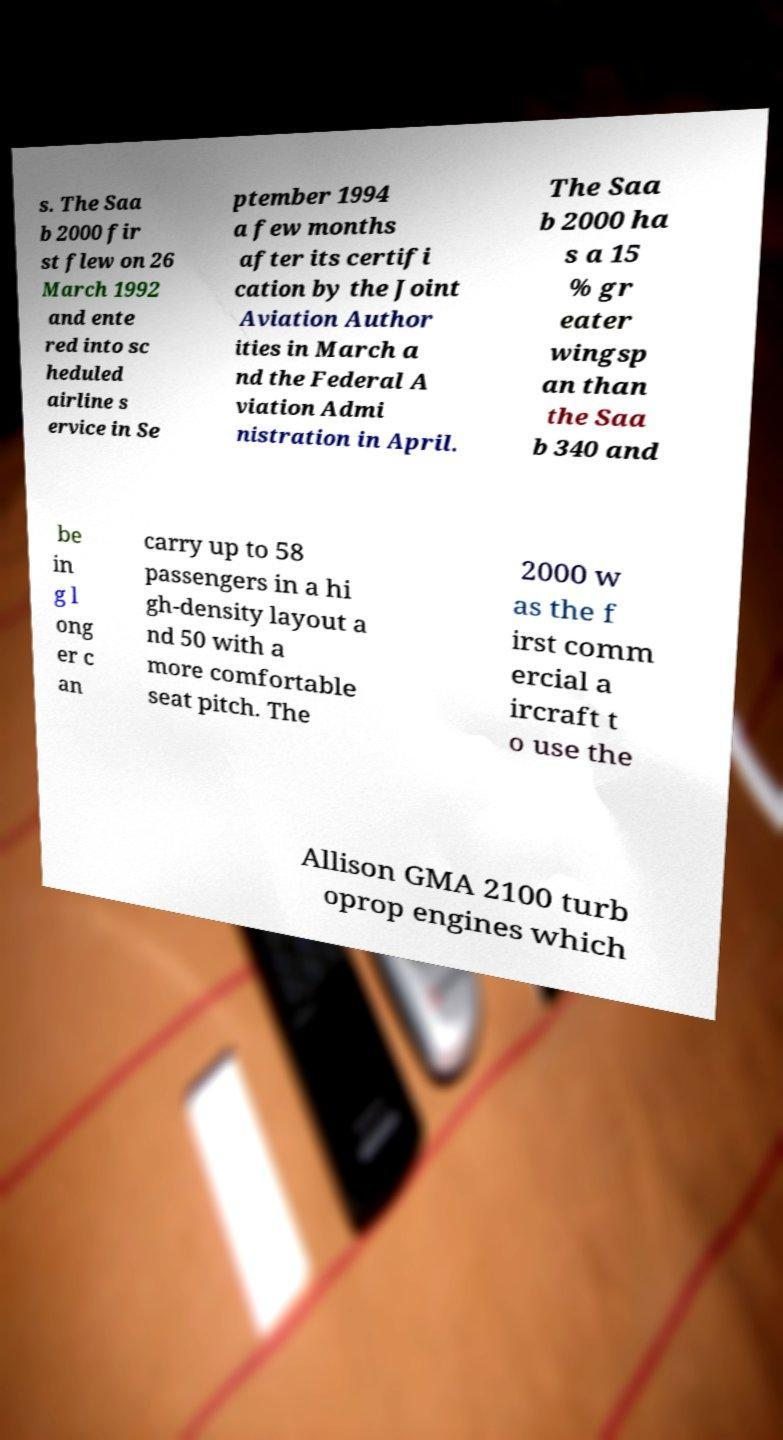There's text embedded in this image that I need extracted. Can you transcribe it verbatim? s. The Saa b 2000 fir st flew on 26 March 1992 and ente red into sc heduled airline s ervice in Se ptember 1994 a few months after its certifi cation by the Joint Aviation Author ities in March a nd the Federal A viation Admi nistration in April. The Saa b 2000 ha s a 15 % gr eater wingsp an than the Saa b 340 and be in g l ong er c an carry up to 58 passengers in a hi gh-density layout a nd 50 with a more comfortable seat pitch. The 2000 w as the f irst comm ercial a ircraft t o use the Allison GMA 2100 turb oprop engines which 